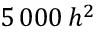Convert formula to latex. <formula><loc_0><loc_0><loc_500><loc_500>5 \, 0 0 0 \, h ^ { 2 }</formula> 